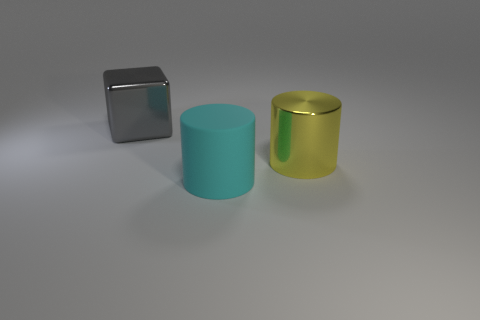Is there any other thing that has the same material as the cyan cylinder?
Offer a very short reply. No. Does the yellow thing have the same size as the gray thing?
Make the answer very short. Yes. Are there any matte cylinders that have the same size as the rubber thing?
Offer a terse response. No. There is a big object on the left side of the cyan cylinder; are there any metal cylinders that are on the right side of it?
Ensure brevity in your answer.  Yes. How many other things are the same shape as the big matte thing?
Provide a short and direct response. 1. Is the big cyan rubber object the same shape as the big gray thing?
Keep it short and to the point. No. What is the color of the large object that is to the left of the yellow metal cylinder and to the right of the large metal block?
Make the answer very short. Cyan. What number of tiny objects are either cubes or yellow objects?
Ensure brevity in your answer.  0. Is there any other thing that is the same color as the block?
Give a very brief answer. No. What is the material of the big thing to the right of the large cylinder that is left of the shiny object that is in front of the gray metallic block?
Provide a short and direct response. Metal. 